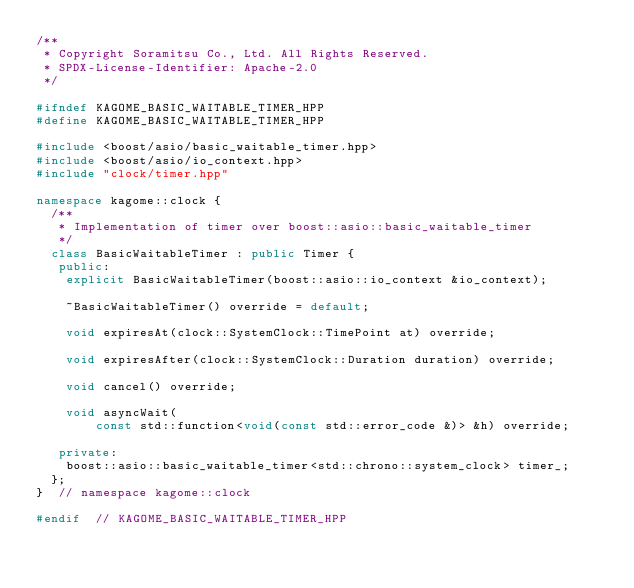<code> <loc_0><loc_0><loc_500><loc_500><_C++_>/**
 * Copyright Soramitsu Co., Ltd. All Rights Reserved.
 * SPDX-License-Identifier: Apache-2.0
 */

#ifndef KAGOME_BASIC_WAITABLE_TIMER_HPP
#define KAGOME_BASIC_WAITABLE_TIMER_HPP

#include <boost/asio/basic_waitable_timer.hpp>
#include <boost/asio/io_context.hpp>
#include "clock/timer.hpp"

namespace kagome::clock {
  /**
   * Implementation of timer over boost::asio::basic_waitable_timer
   */
  class BasicWaitableTimer : public Timer {
   public:
    explicit BasicWaitableTimer(boost::asio::io_context &io_context);

    ~BasicWaitableTimer() override = default;

    void expiresAt(clock::SystemClock::TimePoint at) override;

    void expiresAfter(clock::SystemClock::Duration duration) override;

    void cancel() override;

    void asyncWait(
        const std::function<void(const std::error_code &)> &h) override;

   private:
    boost::asio::basic_waitable_timer<std::chrono::system_clock> timer_;
  };
}  // namespace kagome::clock

#endif  // KAGOME_BASIC_WAITABLE_TIMER_HPP
</code> 